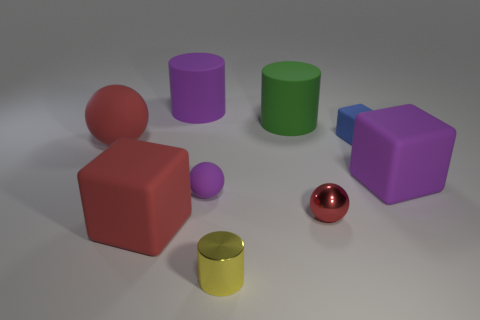Do the tiny metal ball and the big sphere have the same color?
Keep it short and to the point. Yes. Is the shape of the big green rubber object the same as the small blue matte thing?
Provide a succinct answer. No. Is the number of red balls on the left side of the tiny cylinder the same as the number of large rubber cubes right of the blue rubber cube?
Offer a terse response. Yes. What color is the small cube that is the same material as the big purple block?
Provide a short and direct response. Blue. What number of big red cubes have the same material as the big green cylinder?
Ensure brevity in your answer.  1. Does the rubber block that is in front of the purple cube have the same color as the shiny sphere?
Provide a succinct answer. Yes. What number of purple rubber objects are the same shape as the blue object?
Ensure brevity in your answer.  1. Are there an equal number of blue rubber cubes to the left of the big red block and small brown cubes?
Ensure brevity in your answer.  Yes. What is the color of the sphere that is the same size as the red block?
Provide a short and direct response. Red. Is there another tiny blue rubber thing of the same shape as the small blue object?
Keep it short and to the point. No. 